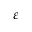Convert formula to latex. <formula><loc_0><loc_0><loc_500><loc_500>\varepsilon</formula> 